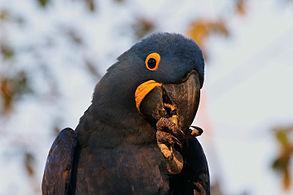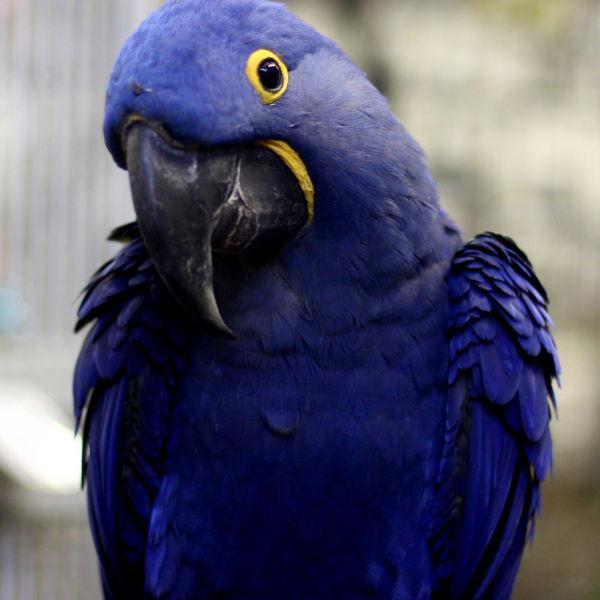The first image is the image on the left, the second image is the image on the right. For the images displayed, is the sentence "In at least one image, a single bird is pictured that lacks a yellow ring around the eye and has a small straight beak." factually correct? Answer yes or no. No. The first image is the image on the left, the second image is the image on the right. Considering the images on both sides, is "All images show a blue-feathered bird perched on something resembling wood." valid? Answer yes or no. No. 